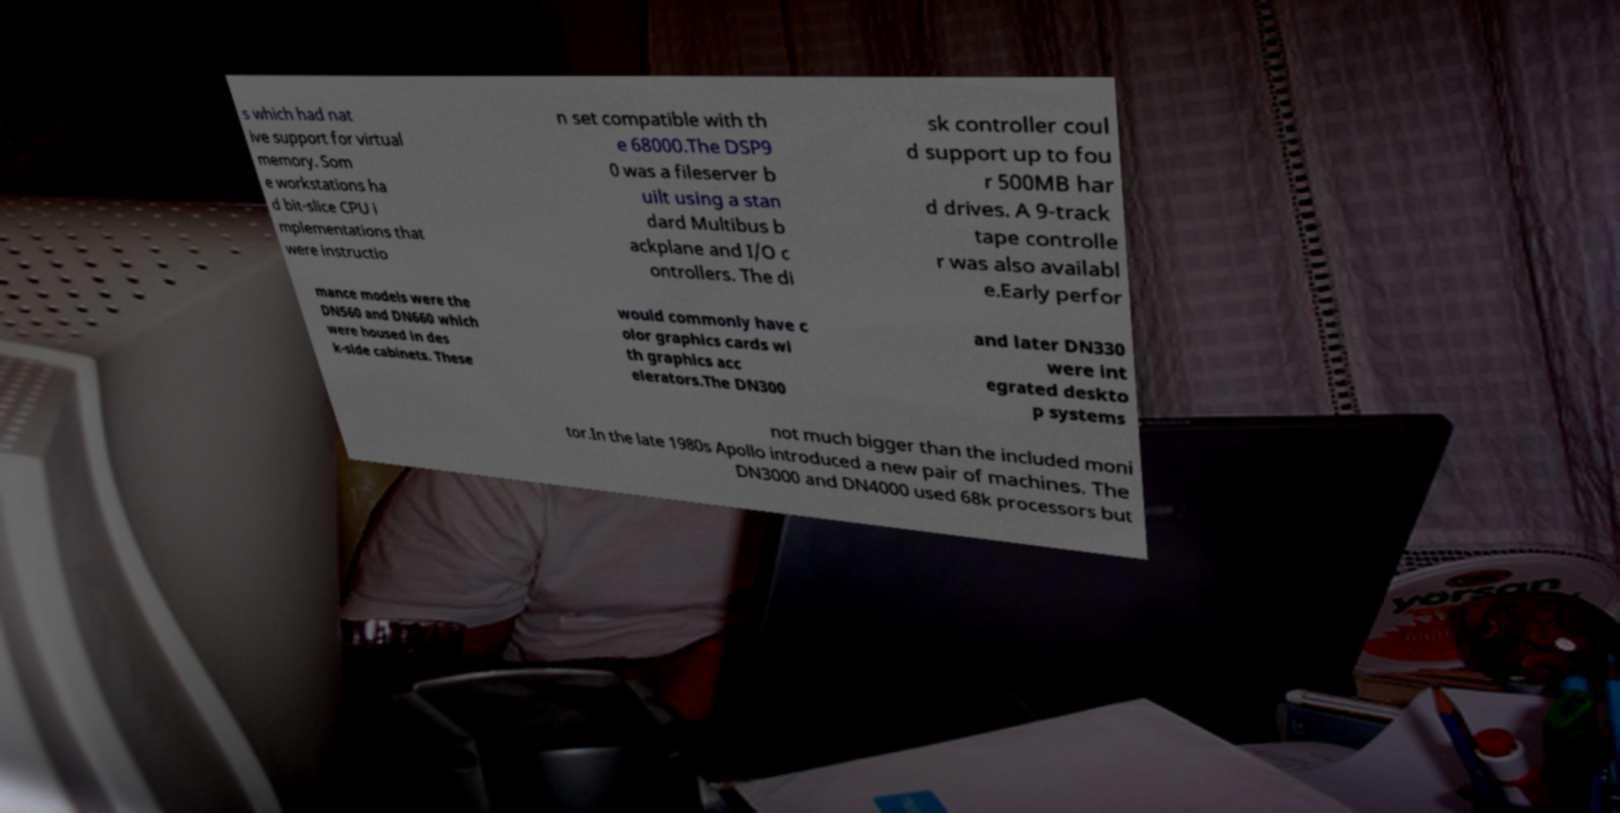Please identify and transcribe the text found in this image. s which had nat ive support for virtual memory. Som e workstations ha d bit-slice CPU i mplementations that were instructio n set compatible with th e 68000.The DSP9 0 was a fileserver b uilt using a stan dard Multibus b ackplane and I/O c ontrollers. The di sk controller coul d support up to fou r 500MB har d drives. A 9-track tape controlle r was also availabl e.Early perfor mance models were the DN560 and DN660 which were housed in des k-side cabinets. These would commonly have c olor graphics cards wi th graphics acc elerators.The DN300 and later DN330 were int egrated deskto p systems not much bigger than the included moni tor.In the late 1980s Apollo introduced a new pair of machines. The DN3000 and DN4000 used 68k processors but 